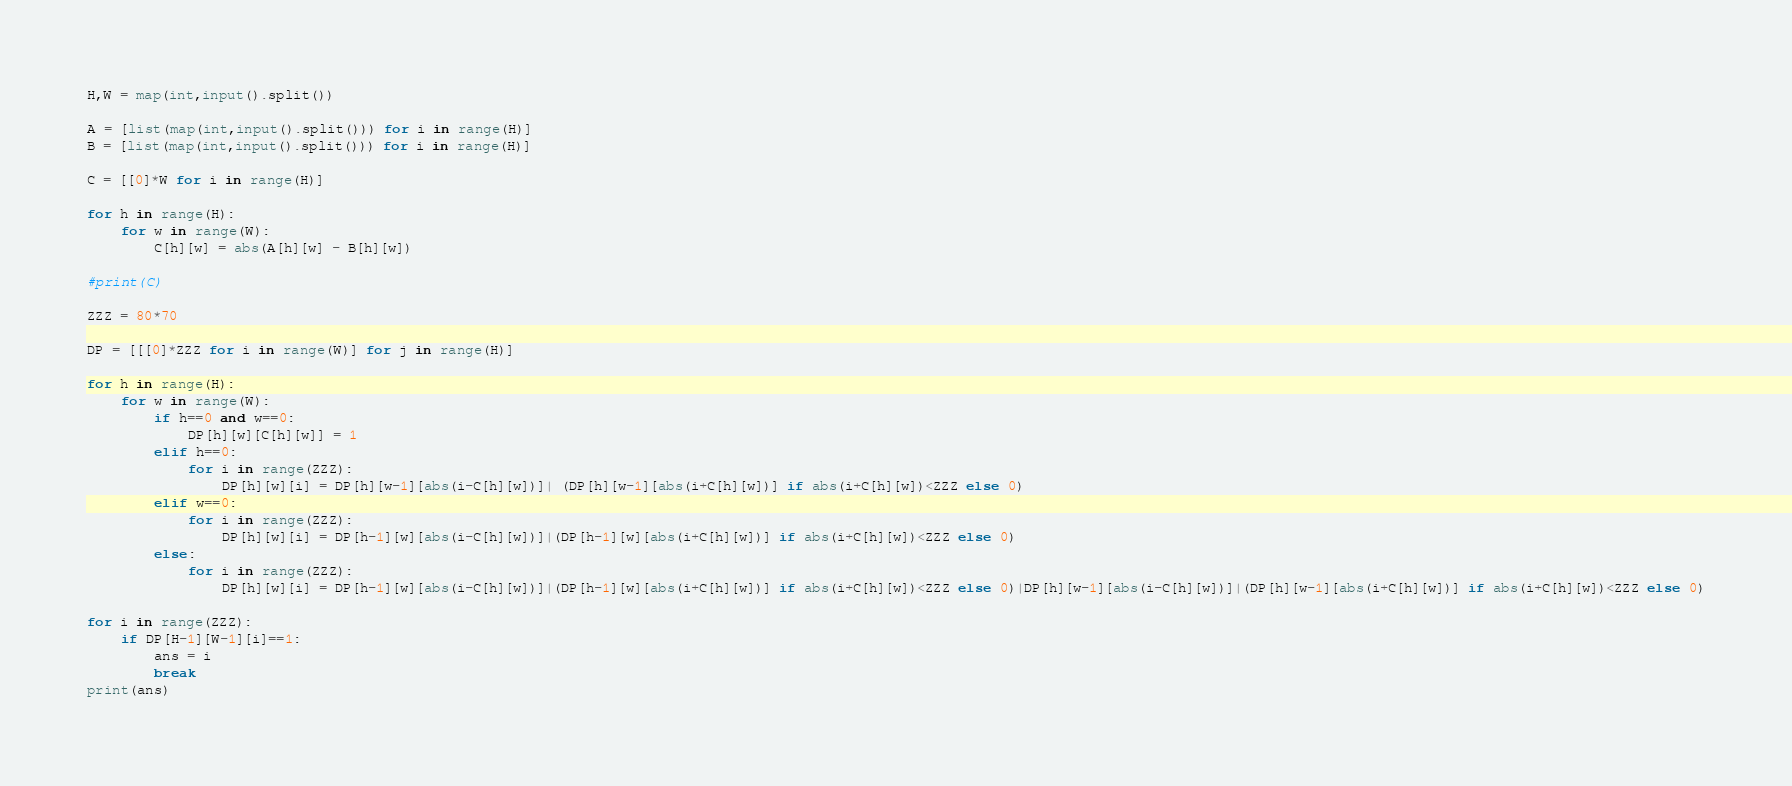Convert code to text. <code><loc_0><loc_0><loc_500><loc_500><_Python_>H,W = map(int,input().split())

A = [list(map(int,input().split())) for i in range(H)]
B = [list(map(int,input().split())) for i in range(H)]

C = [[0]*W for i in range(H)]

for h in range(H):
    for w in range(W):
        C[h][w] = abs(A[h][w] - B[h][w])
        
#print(C)

ZZZ = 80*70

DP = [[[0]*ZZZ for i in range(W)] for j in range(H)]

for h in range(H):
    for w in range(W):
        if h==0 and w==0:
            DP[h][w][C[h][w]] = 1
        elif h==0:
            for i in range(ZZZ):
                DP[h][w][i] = DP[h][w-1][abs(i-C[h][w])]| (DP[h][w-1][abs(i+C[h][w])] if abs(i+C[h][w])<ZZZ else 0)
        elif w==0:
            for i in range(ZZZ):
                DP[h][w][i] = DP[h-1][w][abs(i-C[h][w])]|(DP[h-1][w][abs(i+C[h][w])] if abs(i+C[h][w])<ZZZ else 0)
        else:
            for i in range(ZZZ):
                DP[h][w][i] = DP[h-1][w][abs(i-C[h][w])]|(DP[h-1][w][abs(i+C[h][w])] if abs(i+C[h][w])<ZZZ else 0)|DP[h][w-1][abs(i-C[h][w])]|(DP[h][w-1][abs(i+C[h][w])] if abs(i+C[h][w])<ZZZ else 0)
                
for i in range(ZZZ):
    if DP[H-1][W-1][i]==1:
        ans = i
        break
print(ans)</code> 